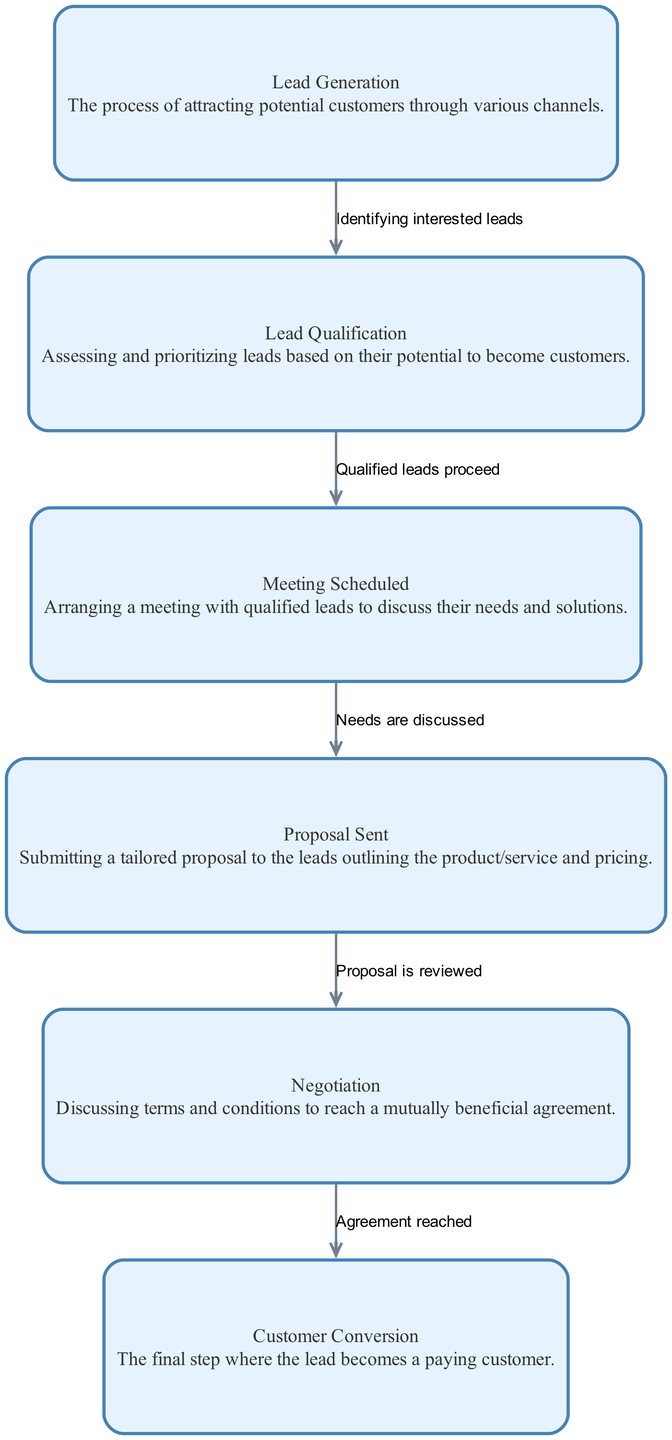What is the first stage in the sales funnel? The first node in the diagram is "Lead Generation," which indicates it is the starting point of the sales process where potential customers are attracted.
Answer: Lead Generation How many nodes are in the sales funnel? By counting the distinct nodes listed, there are six stages from "Lead Generation" to "Customer Conversion."
Answer: Six What is the edge label between "Lead Qualification" and "Meeting Scheduled"? The edge connecting these two nodes is labeled "Qualified leads proceed," which shows the transition from qualification to meeting scheduling.
Answer: Qualified leads proceed Which stage comes before "Negotiation"? The node that directly connects to "Negotiation" is "Proposal Sent," indicating that a proposal must be submitted before negotiation can take place.
Answer: Proposal Sent What is the final stage in the sales funnel? The last node in the sequence is "Customer Conversion," marking the point at which a lead successfully becomes a paying customer.
Answer: Customer Conversion Which stage corresponds to "Arranging a meeting with qualified leads"? The description for the node "Meeting Scheduled" clearly defines it as the stage where meetings are being arranged with qualified leads.
Answer: Meeting Scheduled What do the edges represent in this directed graph? The edges show the flow of the sales process between different stages, indicating the progression from one activity to the next.
Answer: Flow of the sales process How many edges connect the nodes in the sales funnel? By counting the connections (edges) listed, there are five edges that connect the six nodes in the sales funnel diagram.
Answer: Five What step follows after "Proposal Sent"? Following "Proposal Sent," the next step is "Negotiation," where terms of the proposal are discussed.
Answer: Negotiation What is the relationship between "Proposal Sent" and "Customer Conversion"? There is no direct edge connecting "Proposal Sent" to "Customer Conversion"; rather, "Negotiation" must take place first before reaching conversion.
Answer: Indirect relationship via Negotiation 